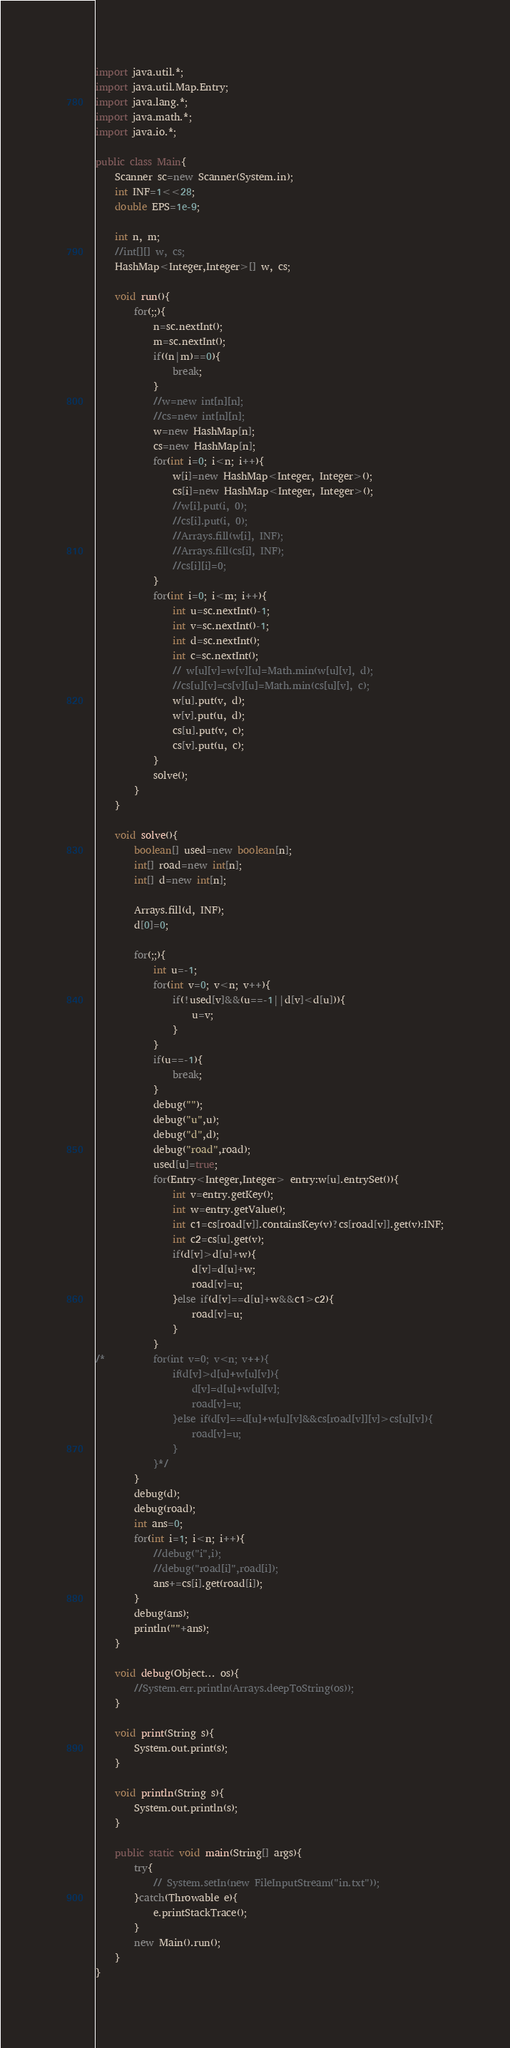Convert code to text. <code><loc_0><loc_0><loc_500><loc_500><_Java_>import java.util.*;
import java.util.Map.Entry;
import java.lang.*;
import java.math.*;
import java.io.*;

public class Main{
	Scanner sc=new Scanner(System.in);
	int INF=1<<28;
	double EPS=1e-9;

	int n, m;
	//int[][] w, cs;
	HashMap<Integer,Integer>[] w, cs;

	void run(){
		for(;;){
			n=sc.nextInt();
			m=sc.nextInt();
			if((n|m)==0){
				break;
			}
			//w=new int[n][n];
			//cs=new int[n][n];
			w=new HashMap[n];
			cs=new HashMap[n];
			for(int i=0; i<n; i++){
				w[i]=new HashMap<Integer, Integer>();
				cs[i]=new HashMap<Integer, Integer>();
				//w[i].put(i, 0);
				//cs[i].put(i, 0);
				//Arrays.fill(w[i], INF);
				//Arrays.fill(cs[i], INF);
				//cs[i][i]=0;
			}
			for(int i=0; i<m; i++){
				int u=sc.nextInt()-1;
				int v=sc.nextInt()-1;
				int d=sc.nextInt();
				int c=sc.nextInt();
				// w[u][v]=w[v][u]=Math.min(w[u][v], d);
				//cs[u][v]=cs[v][u]=Math.min(cs[u][v], c);
				w[u].put(v, d);
				w[v].put(u, d);
				cs[u].put(v, c);
				cs[v].put(u, c);
			}
			solve();
		}
	}

	void solve(){
		boolean[] used=new boolean[n];
		int[] road=new int[n];
		int[] d=new int[n];

		Arrays.fill(d, INF);
		d[0]=0;

		for(;;){
			int u=-1;
			for(int v=0; v<n; v++){
				if(!used[v]&&(u==-1||d[v]<d[u])){
					u=v;
				}
			}
			if(u==-1){
				break;
			}
			debug("");
			debug("u",u);
			debug("d",d);
			debug("road",road);
			used[u]=true;
			for(Entry<Integer,Integer> entry:w[u].entrySet()){
				int v=entry.getKey();
				int w=entry.getValue();
				int c1=cs[road[v]].containsKey(v)?cs[road[v]].get(v):INF;
				int c2=cs[u].get(v);
				if(d[v]>d[u]+w){
					d[v]=d[u]+w;
					road[v]=u;
				}else if(d[v]==d[u]+w&&c1>c2){
					road[v]=u;
				}
			}
/*			for(int v=0; v<n; v++){
				if(d[v]>d[u]+w[u][v]){
					d[v]=d[u]+w[u][v];
					road[v]=u;
				}else if(d[v]==d[u]+w[u][v]&&cs[road[v]][v]>cs[u][v]){
					road[v]=u;
				}
			}*/
		}
		debug(d);
		debug(road);
		int ans=0;
		for(int i=1; i<n; i++){
			//debug("i",i);
			//debug("road[i]",road[i]);
			ans+=cs[i].get(road[i]);
		}
		debug(ans);
		println(""+ans);
	}

	void debug(Object... os){
		//System.err.println(Arrays.deepToString(os));
	}

	void print(String s){
		System.out.print(s);
	}

	void println(String s){
		System.out.println(s);
	}

	public static void main(String[] args){
		try{
			// System.setIn(new FileInputStream("in.txt"));
		}catch(Throwable e){
			e.printStackTrace();
		}
		new Main().run();
	}
}</code> 